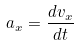Convert formula to latex. <formula><loc_0><loc_0><loc_500><loc_500>a _ { x } = \frac { d v _ { x } } { d t }</formula> 